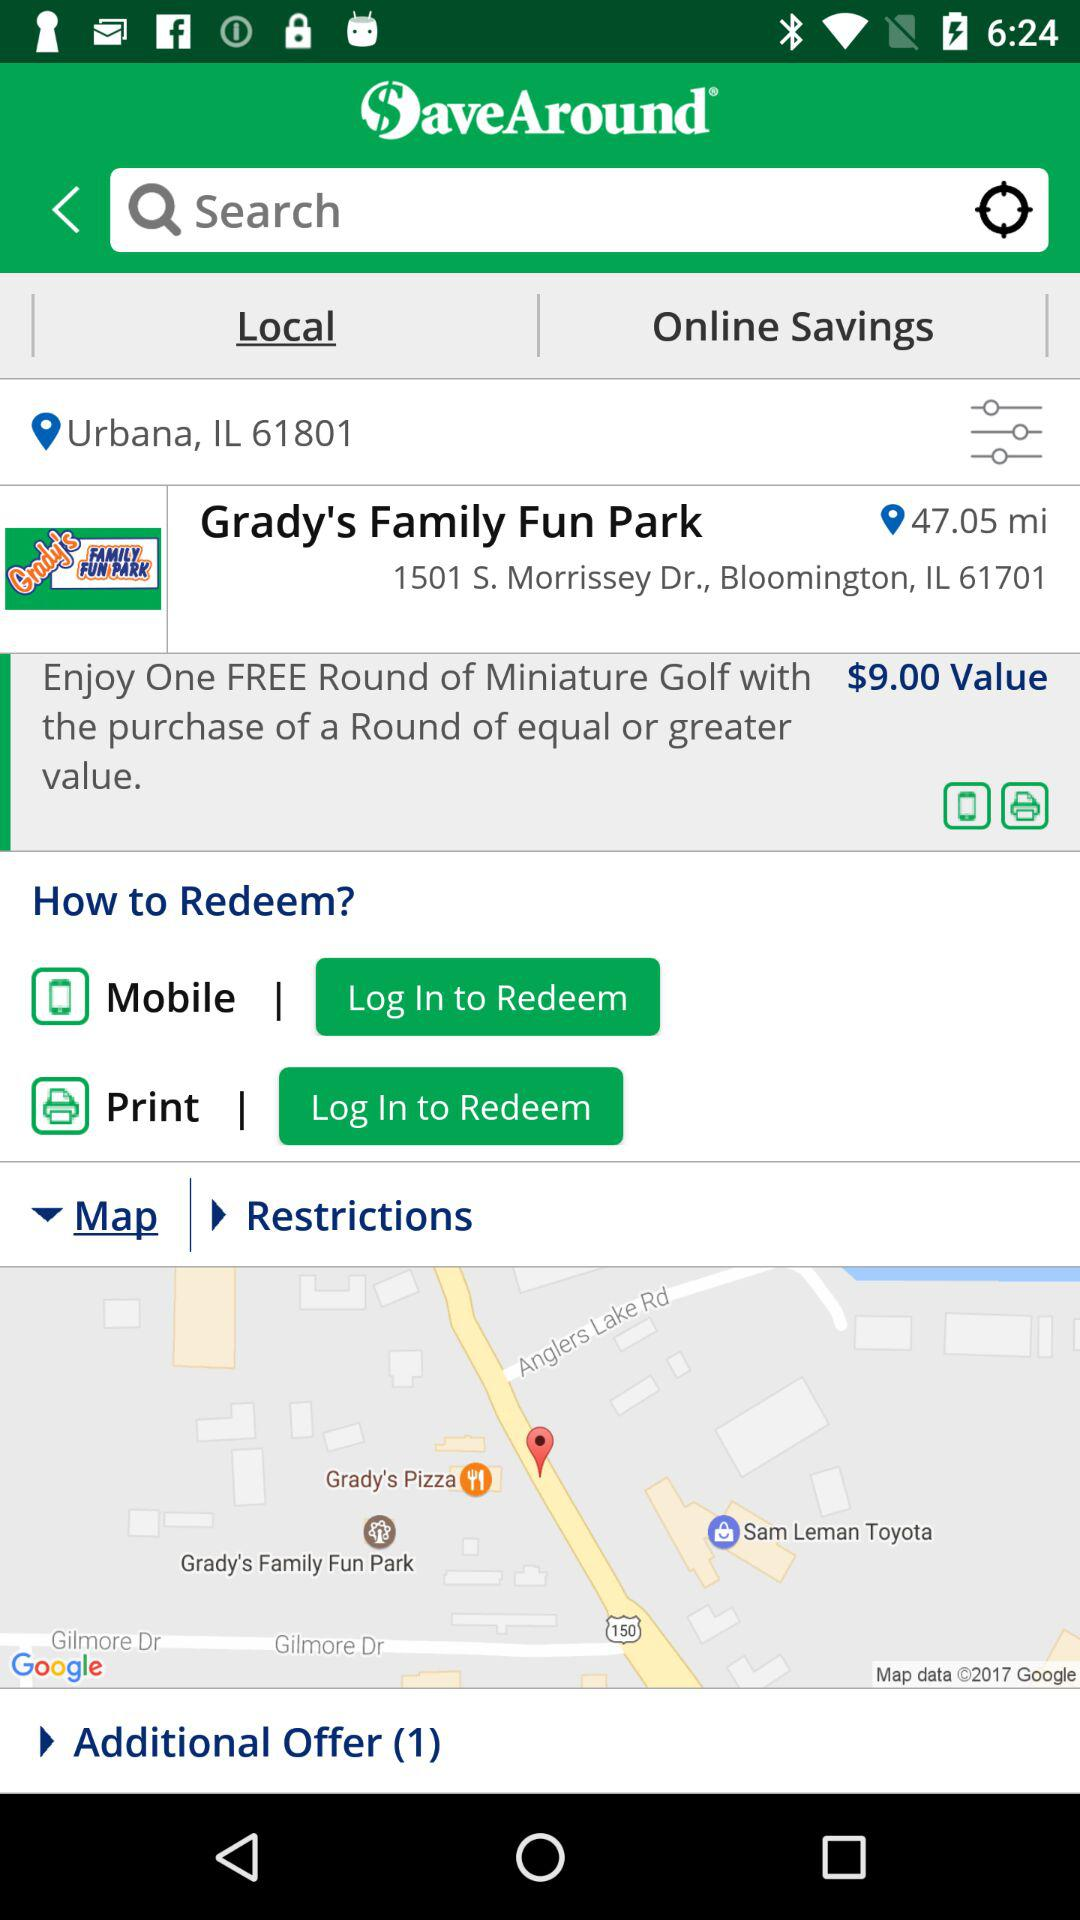How many redemption options are there?
Answer the question using a single word or phrase. 2 